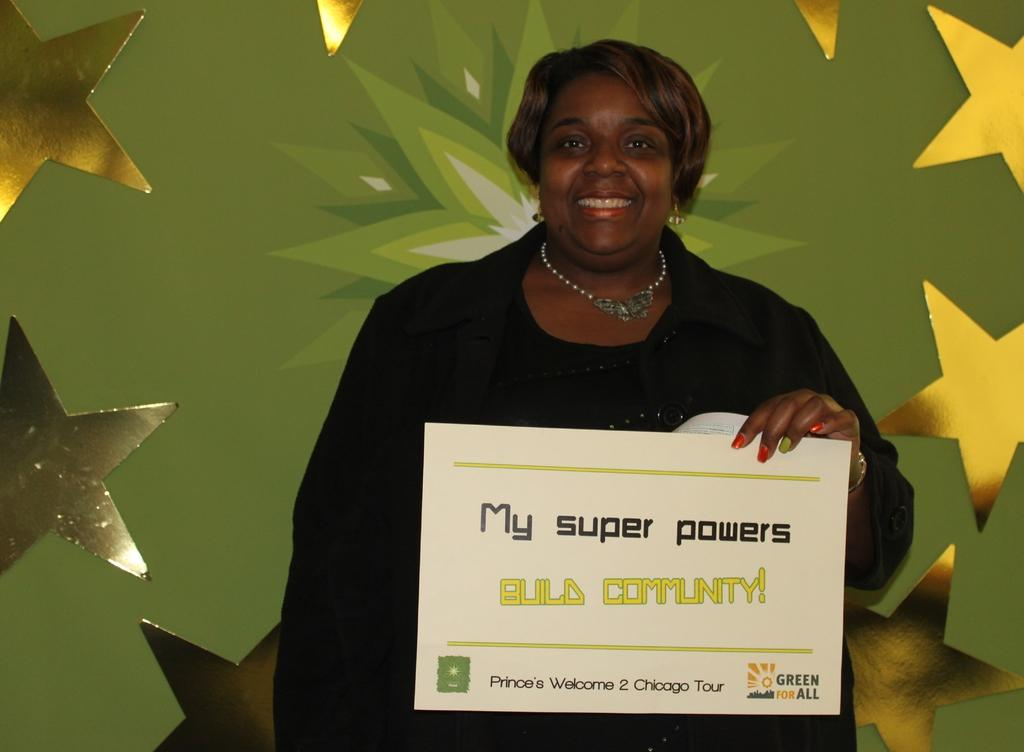Who is the main subject in the image? There is a woman in the image. What is the woman holding in her hand? The woman is holding a card in her hand. What is the woman wearing? The woman is wearing a black dress. What shapes can be seen around the woman? There are star-shaped things around her. How many rings can be seen on the ground in the image? There are no rings visible on the ground in the image. 